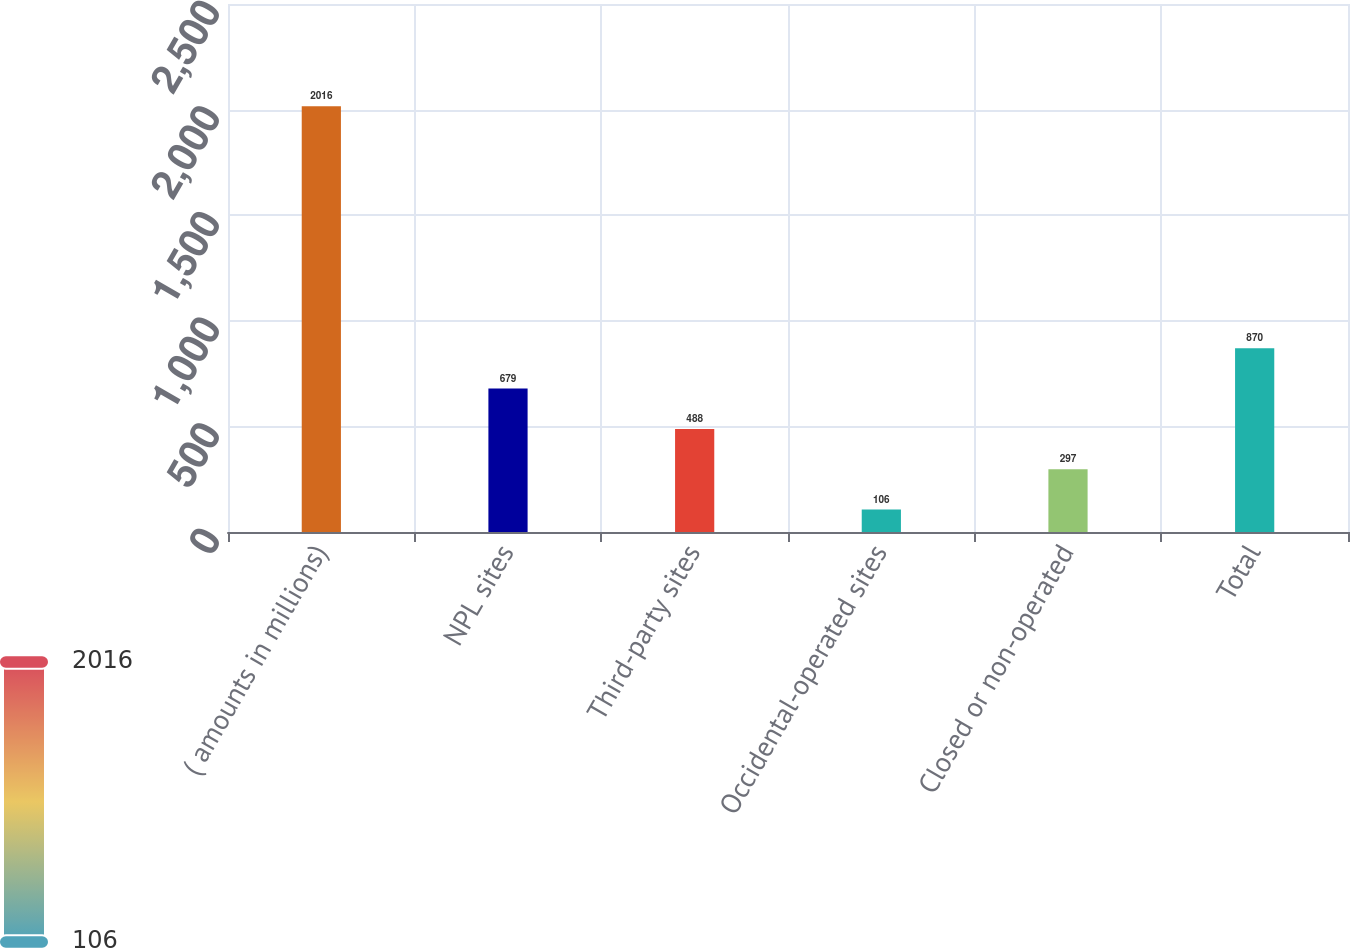<chart> <loc_0><loc_0><loc_500><loc_500><bar_chart><fcel>( amounts in millions)<fcel>NPL sites<fcel>Third-party sites<fcel>Occidental-operated sites<fcel>Closed or non-operated<fcel>Total<nl><fcel>2016<fcel>679<fcel>488<fcel>106<fcel>297<fcel>870<nl></chart> 